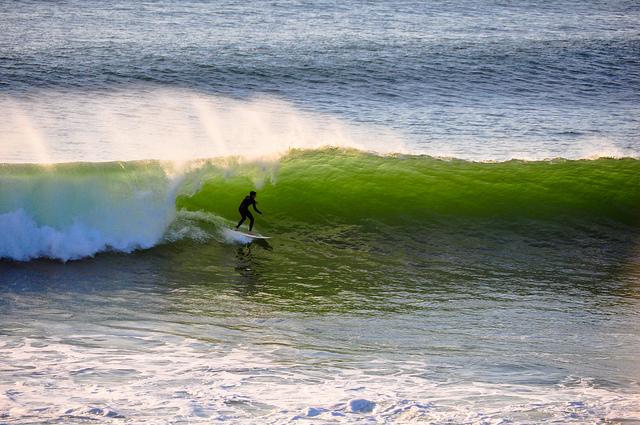What is the person riding?
Be succinct. Surfboard. Why does the wave look green?
Answer briefly. Sun. Is this a tall wave?
Give a very brief answer. Yes. 